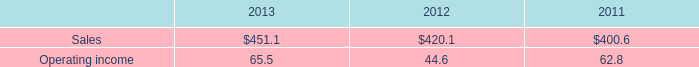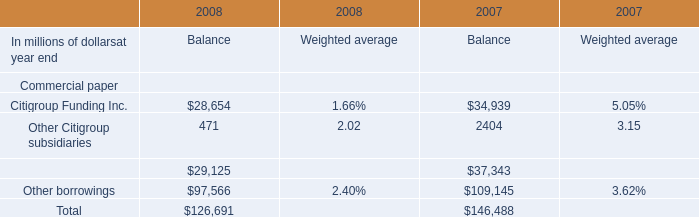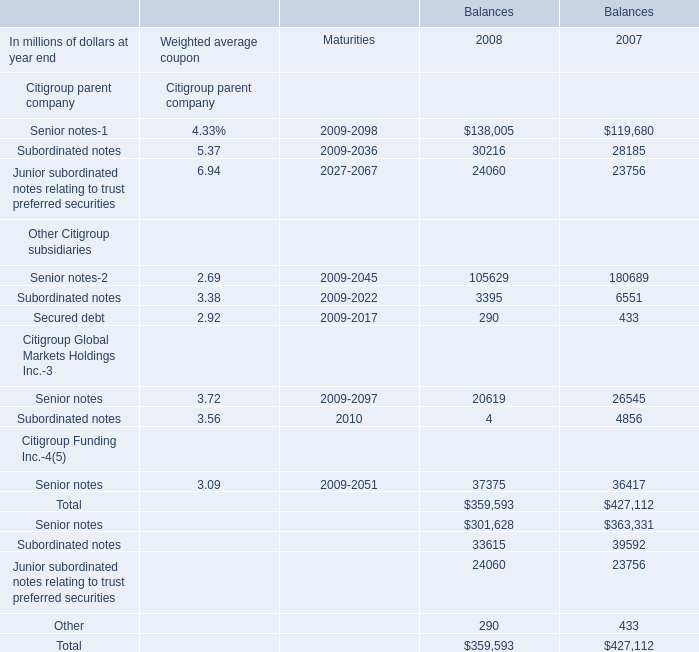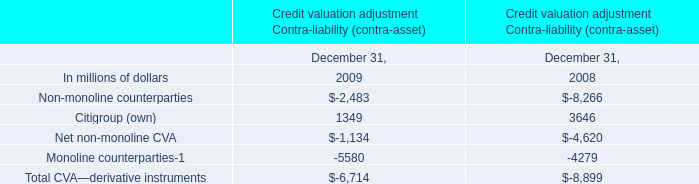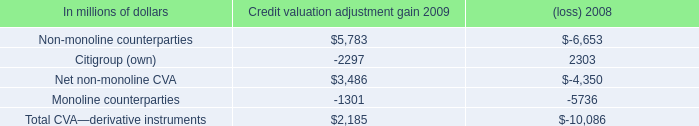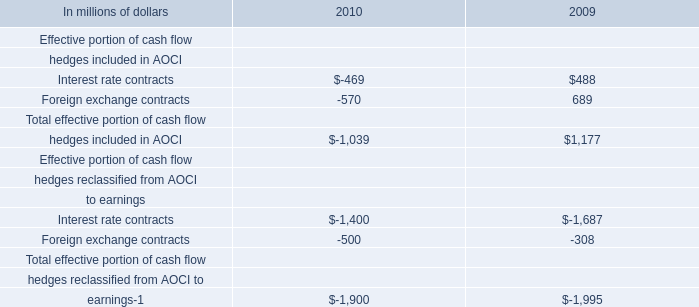What is the sum of the Subordinated notes in the years for Balances where Senior notes is positive? (in million) 
Computations: (30216 + 28185)
Answer: 58401.0. 